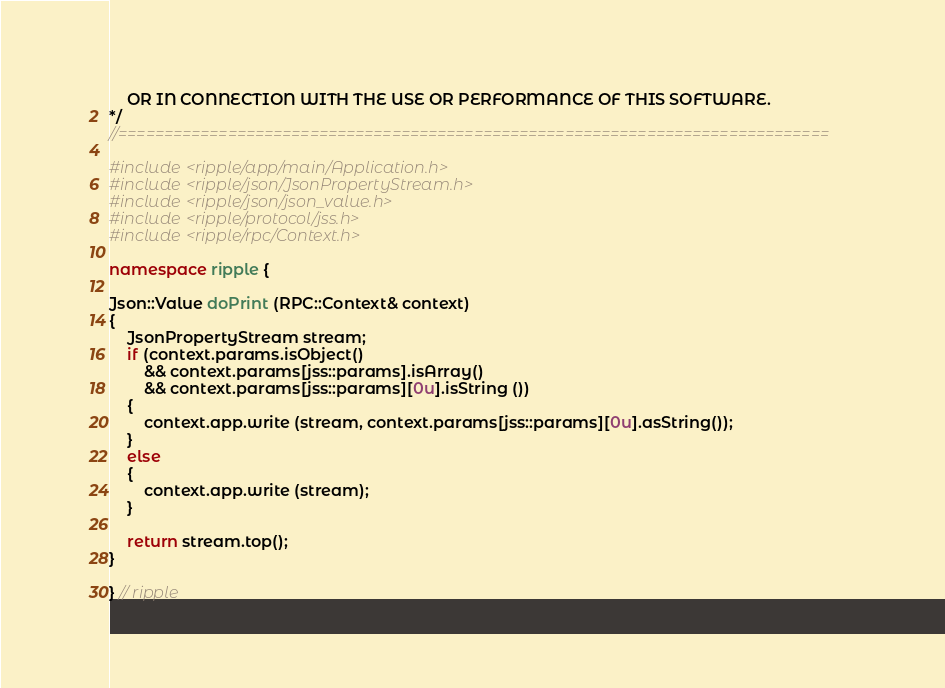<code> <loc_0><loc_0><loc_500><loc_500><_C++_>    OR IN CONNECTION WITH THE USE OR PERFORMANCE OF THIS SOFTWARE.
*/
//==============================================================================

#include <ripple/app/main/Application.h>
#include <ripple/json/JsonPropertyStream.h>
#include <ripple/json/json_value.h>
#include <ripple/protocol/jss.h>
#include <ripple/rpc/Context.h>

namespace ripple {

Json::Value doPrint (RPC::Context& context)
{
    JsonPropertyStream stream;
    if (context.params.isObject()
        && context.params[jss::params].isArray()
        && context.params[jss::params][0u].isString ())
    {
        context.app.write (stream, context.params[jss::params][0u].asString());
    }
    else
    {
        context.app.write (stream);
    }

    return stream.top();
}

} // ripple
</code> 